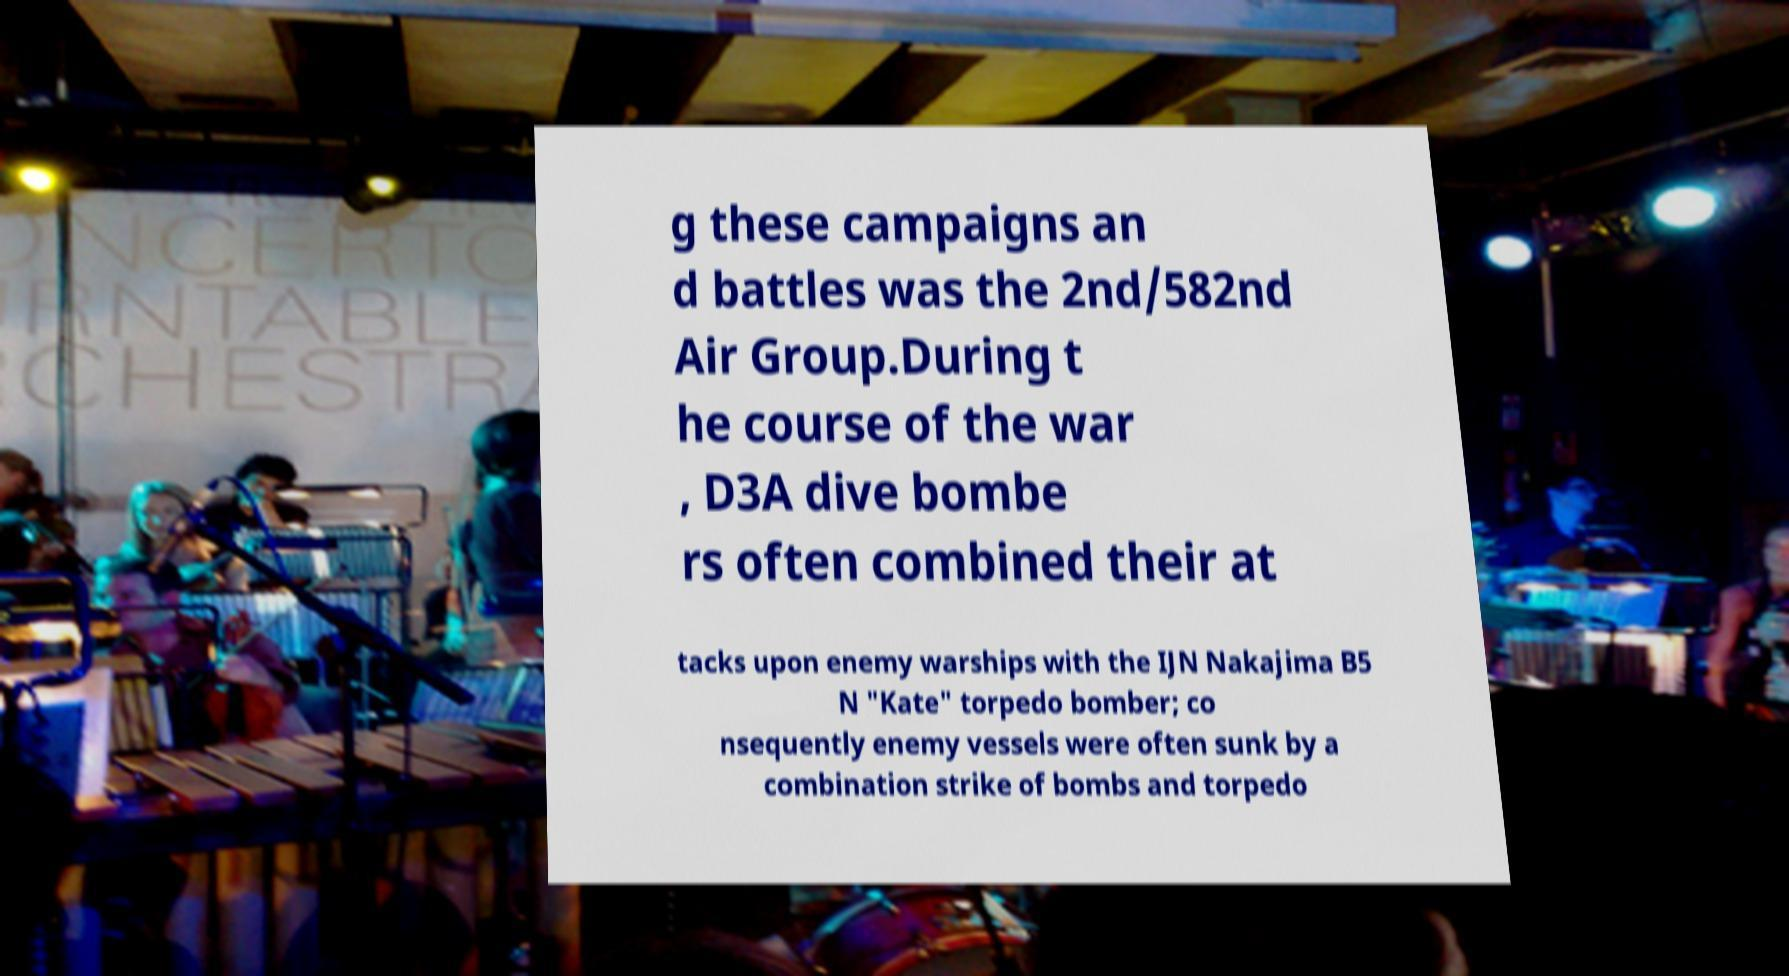Could you assist in decoding the text presented in this image and type it out clearly? g these campaigns an d battles was the 2nd/582nd Air Group.During t he course of the war , D3A dive bombe rs often combined their at tacks upon enemy warships with the IJN Nakajima B5 N "Kate" torpedo bomber; co nsequently enemy vessels were often sunk by a combination strike of bombs and torpedo 